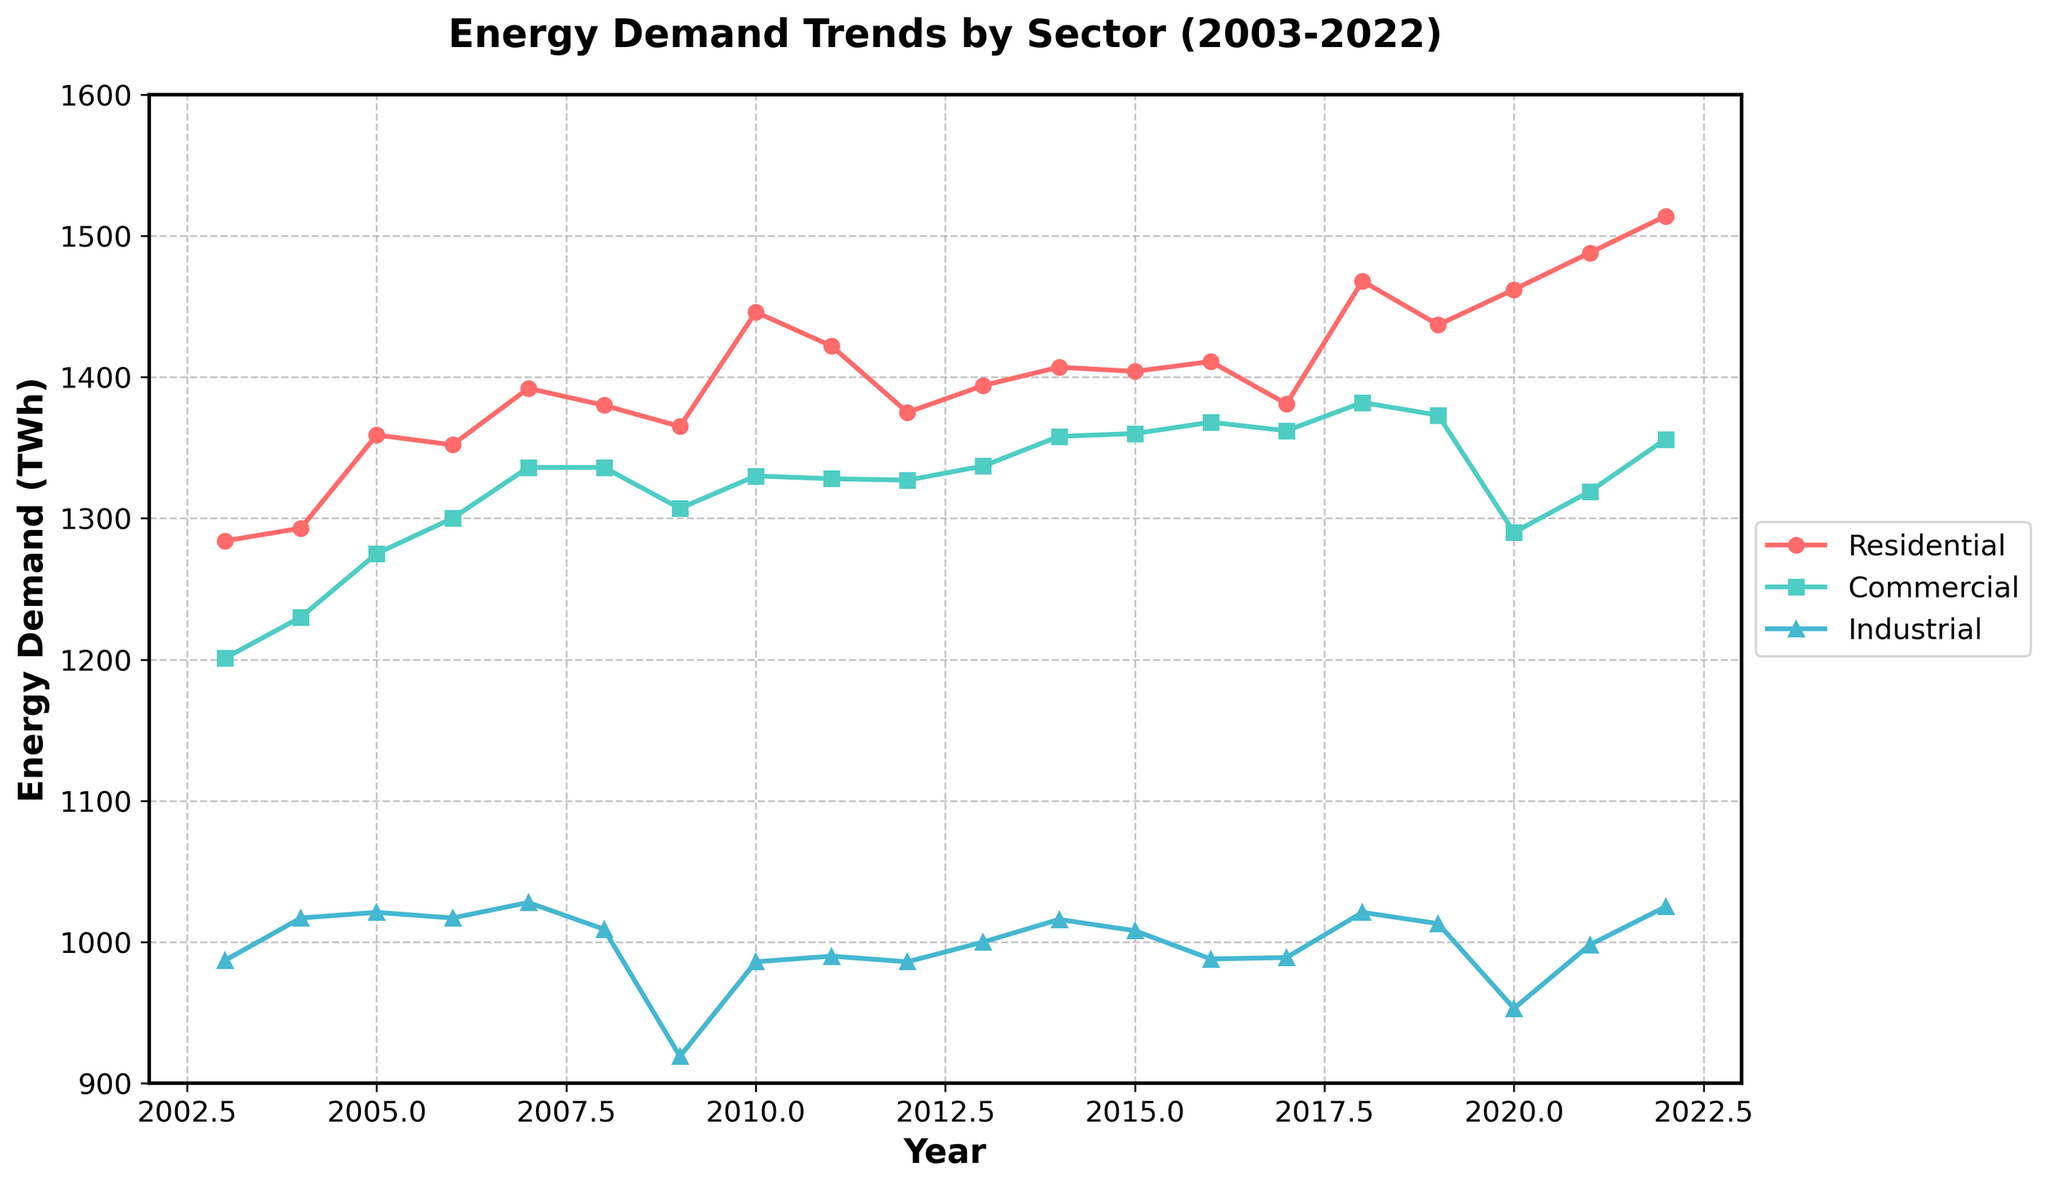What is the overall trend in energy demand for the residential sector from 2003 to 2022? The overall trend for the residential sector shows an increase in energy demand, starting from 1284 TWh in 2003 and rising steadily to 1514 TWh in 2022.
Answer: Increasing Which sector experienced the most significant decrease in energy demand in any single year, and what was the amount? The industrial sector experienced the most significant decrease in energy demand from 2008 to 2009, where it dropped from 1009 TWh to 919 TWh, a decrease of 90 TWh.
Answer: Industrial, 90 TWh In which year did the commercial sector surpass the energy demand of the residential sector, and by how much? In no year did the commercial sector's energy demand surpass that of the residential sector from 2003 to 2022, based on the provided data.
Answer: None What is the average energy demand for the industrial sector over the 20-year period? To find the average, sum the energy demands for each year in the industrial sector and divide by the number of years. The total is (987 + 1017 + 1021 + 1017 + 1028 + 1009 + 919 + 986 + 990 + 986 + 1000 + 1016 + 1008 + 988 + 989 + 1021 + 1013 + 953 + 998 + 1025) = 19861 TWh. Dividing 19861 by 20 gives an average of 993.05 TWh.
Answer: 993.05 TWh Which years show a peak in energy demand for the residential sector? The years 2021 and 2022 show peaks in energy demand for the residential sector with values of 1488 TWh and 1514 TWh, respectively.
Answer: 2021, 2022 Between which consecutive years did the commercial sector see its largest growth in energy demand, and what was the growth? The largest growth in energy demand for the commercial sector was between 2004 and 2005, where it increased from 1230 TWh to 1275 TWh, a growth of 45 TWh.
Answer: 2004 to 2005, 45 TWh By how much did the energy demand in the industrial sector change from the beginning of the observed period (2003) to the end (2022)? The energy demand for the industrial sector in 2003 was 987 TWh and in 2022 it was 1025 TWh. The change in demand is 1025 - 987 = 38 TWh.
Answer: 38 TWh How does the energy demand trend for the commercial sector from 2008 to 2022 compare visually with that of the residential sector over the same period? Visually, the commercial sector shows a relatively steady demand with small fluctuations around 1300-1380 TWh, while the residential sector shows a more pronounced upward trend, rising from 1380 TWh in 2008 to 1514 TWh in 2022.
Answer: Steady vs. Upward What is the combined energy demand for all three sectors in the year 2015? The energy demands for 2015 are: Residential = 1404 TWh, Commercial = 1360 TWh, and Industrial = 1008 TWh. The combined energy demand is 1404 + 1360 + 1008 = 3772 TWh.
Answer: 3772 TWh What visual attribute distinguishes the industrial sector trend line from the other two sectors? The industrial sector is represented by a blue color, using triangle markers ('^'), while the residential sector uses red circles and the commercial sector uses green squares.
Answer: Blue line with triangles 